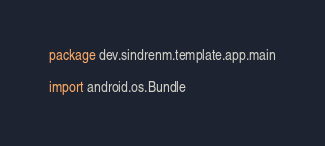Convert code to text. <code><loc_0><loc_0><loc_500><loc_500><_Kotlin_>package dev.sindrenm.template.app.main

import android.os.Bundle</code> 